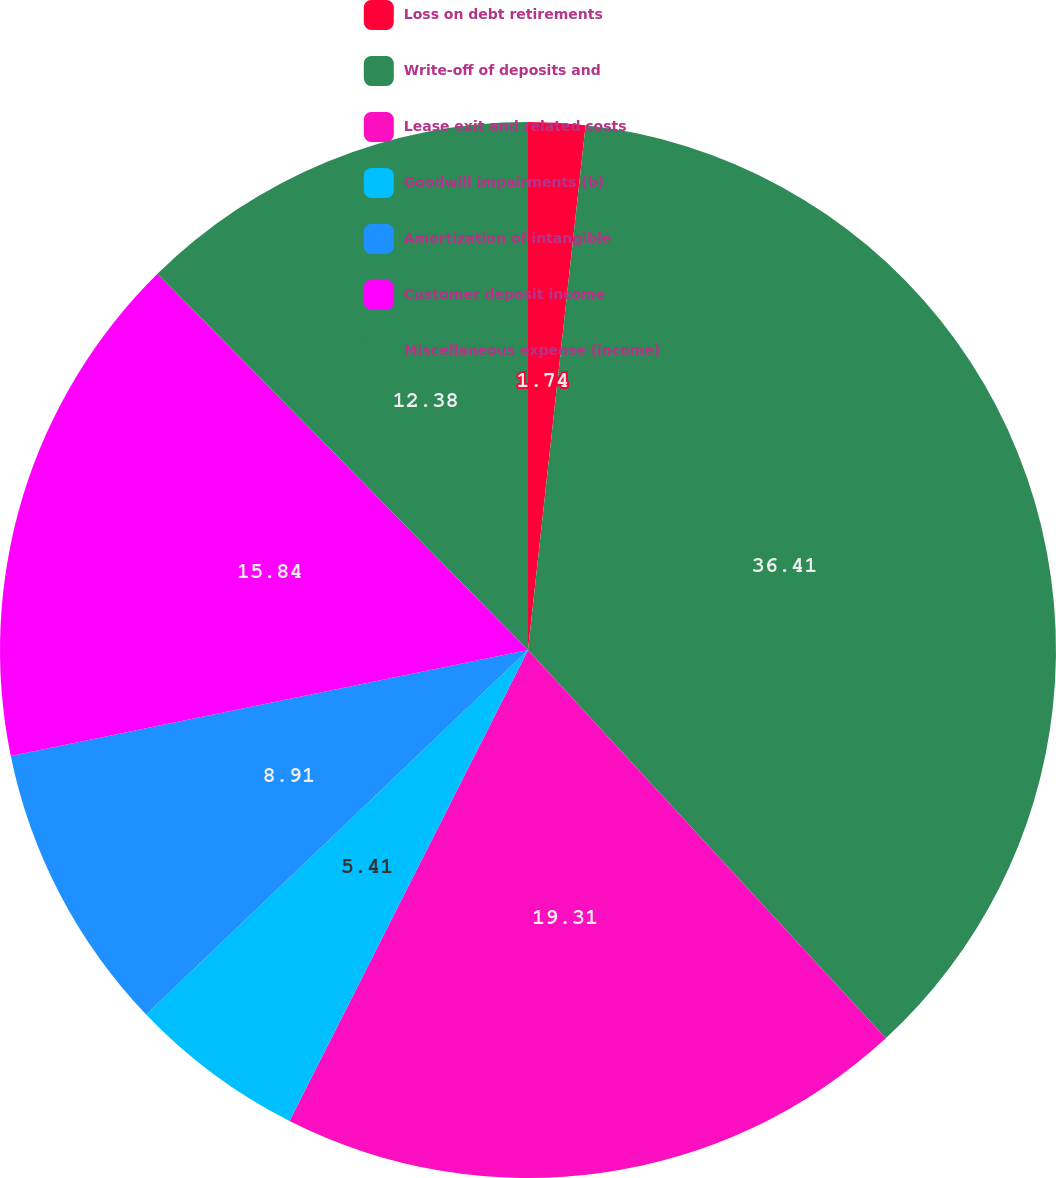<chart> <loc_0><loc_0><loc_500><loc_500><pie_chart><fcel>Loss on debt retirements<fcel>Write-off of deposits and<fcel>Lease exit and related costs<fcel>Goodwill impairments (b)<fcel>Amortization of intangible<fcel>Customer deposit income<fcel>Miscellaneous expense (income)<nl><fcel>1.74%<fcel>36.41%<fcel>19.31%<fcel>5.41%<fcel>8.91%<fcel>15.84%<fcel>12.38%<nl></chart> 